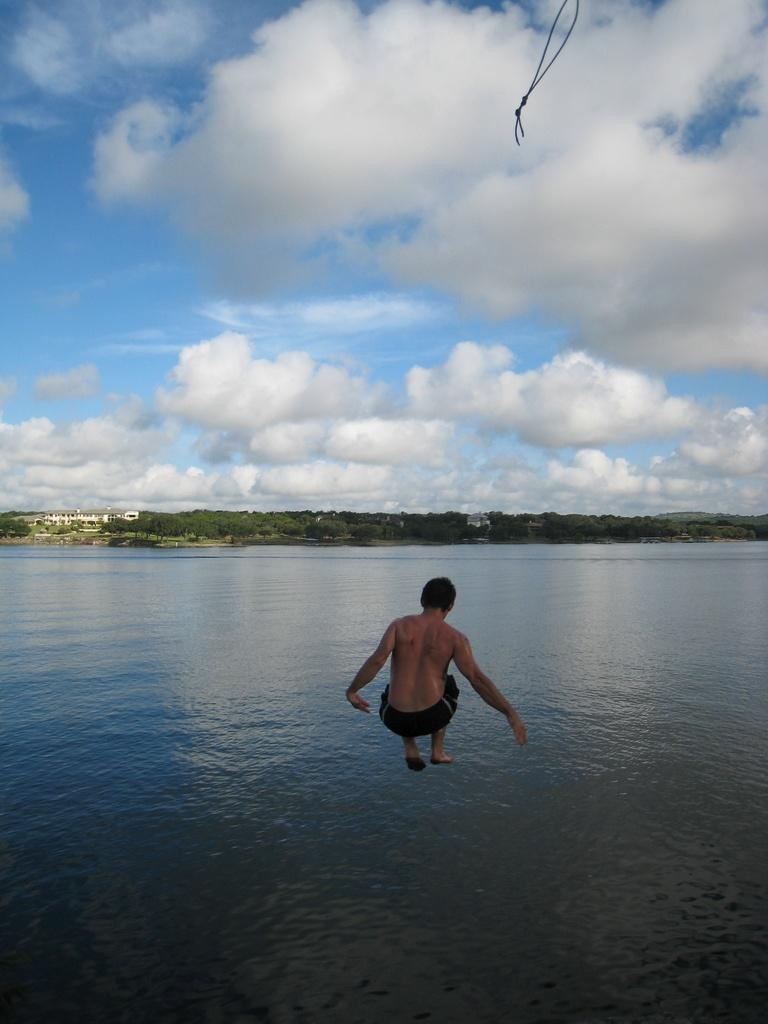What is the color of the sky in the image? The sky is blue in the image. Are there any clouds in the sky in the image? Yes, the sky is cloudy in the image. Can you describe the person in the image? There is a person in the image, and they are jumping into the water. How many girls are talking to the person's grandmother in the image? There are no girls or grandmothers present in the image. 